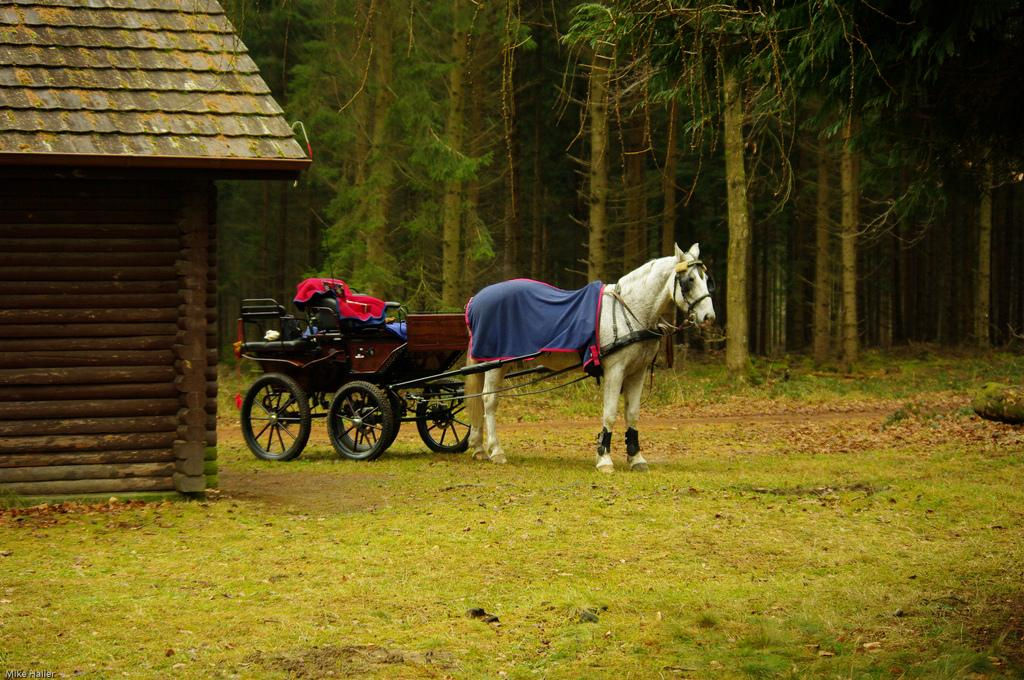What type of animal is in the image? There is a white color horse in the image. What is the horse pulling in the image? There is a cart in the image that the horse is pulling. What type of structure is visible in the image? There is a house in the image. What type of vegetation is present in the image? There is grass and trees in the image. What type of can is being used to water the trees in the image? There is no can present in the image, and the trees do not appear to be watered. 